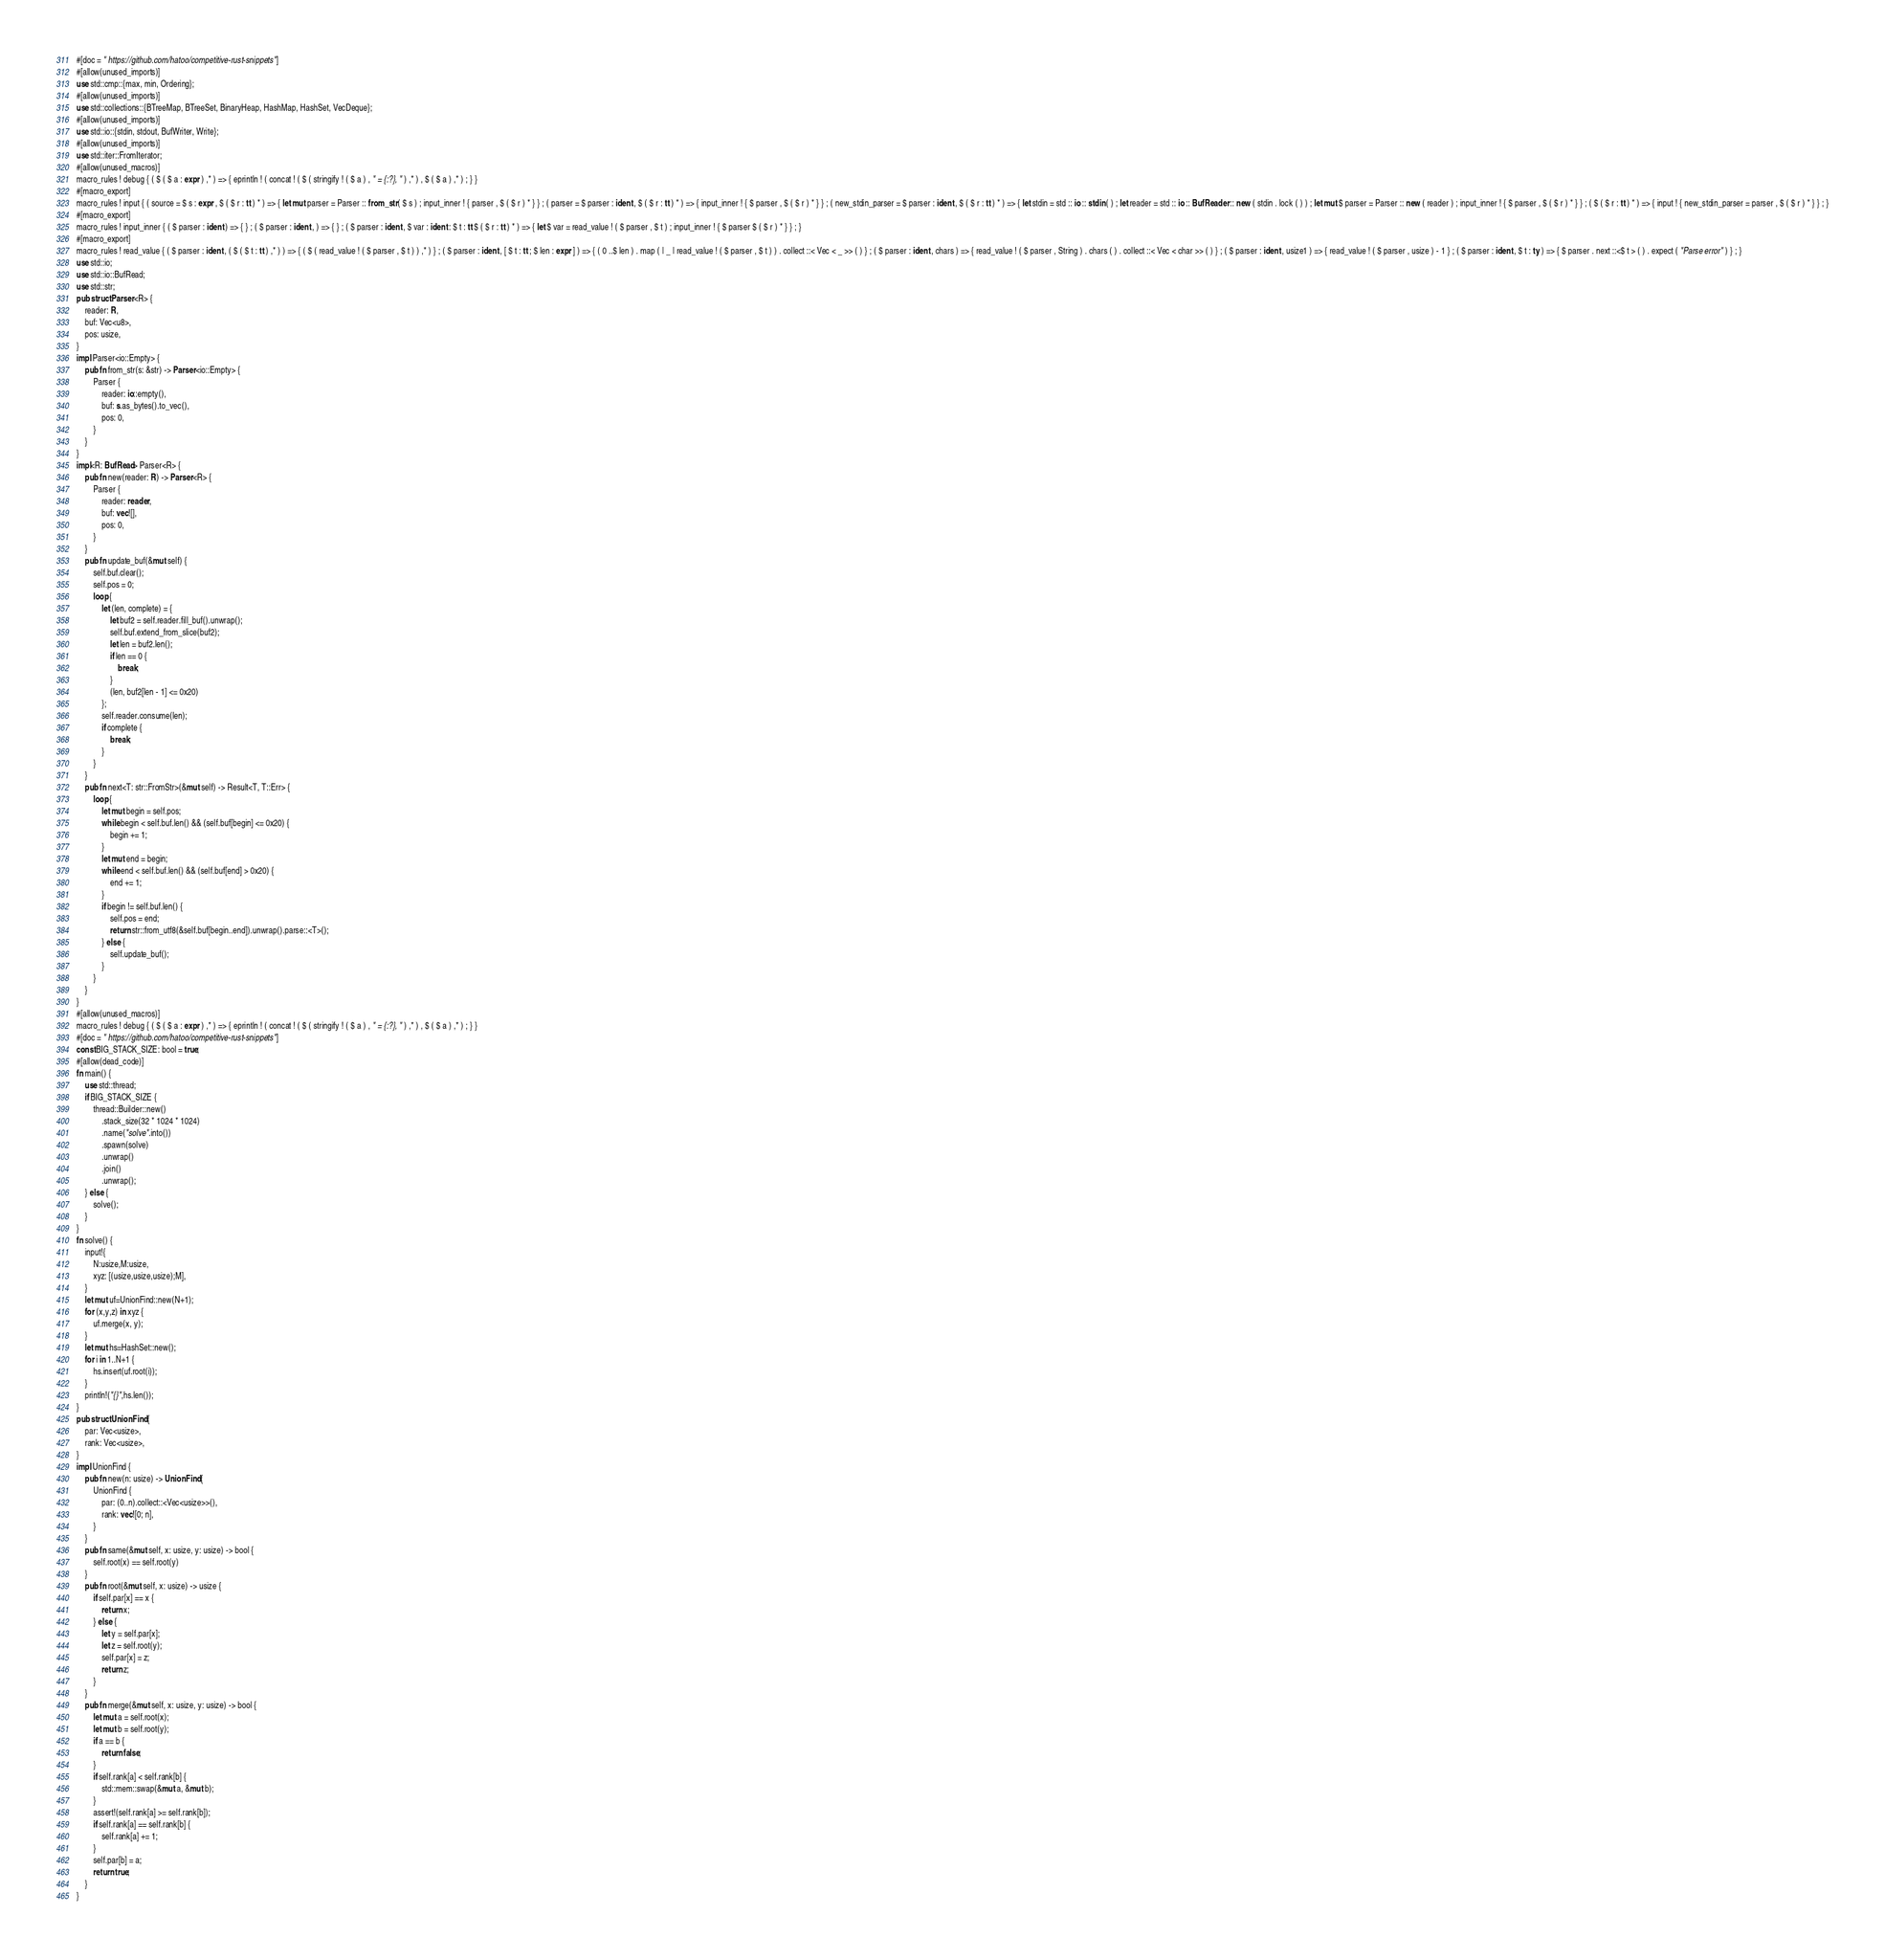Convert code to text. <code><loc_0><loc_0><loc_500><loc_500><_Rust_>#[doc = " https://github.com/hatoo/competitive-rust-snippets"]
#[allow(unused_imports)]
use std::cmp::{max, min, Ordering};
#[allow(unused_imports)]
use std::collections::{BTreeMap, BTreeSet, BinaryHeap, HashMap, HashSet, VecDeque};
#[allow(unused_imports)]
use std::io::{stdin, stdout, BufWriter, Write};
#[allow(unused_imports)]
use std::iter::FromIterator;
#[allow(unused_macros)]
macro_rules ! debug { ( $ ( $ a : expr ) ,* ) => { eprintln ! ( concat ! ( $ ( stringify ! ( $ a ) , " = {:?}, " ) ,* ) , $ ( $ a ) ,* ) ; } }
#[macro_export]
macro_rules ! input { ( source = $ s : expr , $ ( $ r : tt ) * ) => { let mut parser = Parser :: from_str ( $ s ) ; input_inner ! { parser , $ ( $ r ) * } } ; ( parser = $ parser : ident , $ ( $ r : tt ) * ) => { input_inner ! { $ parser , $ ( $ r ) * } } ; ( new_stdin_parser = $ parser : ident , $ ( $ r : tt ) * ) => { let stdin = std :: io :: stdin ( ) ; let reader = std :: io :: BufReader :: new ( stdin . lock ( ) ) ; let mut $ parser = Parser :: new ( reader ) ; input_inner ! { $ parser , $ ( $ r ) * } } ; ( $ ( $ r : tt ) * ) => { input ! { new_stdin_parser = parser , $ ( $ r ) * } } ; }
#[macro_export]
macro_rules ! input_inner { ( $ parser : ident ) => { } ; ( $ parser : ident , ) => { } ; ( $ parser : ident , $ var : ident : $ t : tt $ ( $ r : tt ) * ) => { let $ var = read_value ! ( $ parser , $ t ) ; input_inner ! { $ parser $ ( $ r ) * } } ; }
#[macro_export]
macro_rules ! read_value { ( $ parser : ident , ( $ ( $ t : tt ) ,* ) ) => { ( $ ( read_value ! ( $ parser , $ t ) ) ,* ) } ; ( $ parser : ident , [ $ t : tt ; $ len : expr ] ) => { ( 0 ..$ len ) . map ( | _ | read_value ! ( $ parser , $ t ) ) . collect ::< Vec < _ >> ( ) } ; ( $ parser : ident , chars ) => { read_value ! ( $ parser , String ) . chars ( ) . collect ::< Vec < char >> ( ) } ; ( $ parser : ident , usize1 ) => { read_value ! ( $ parser , usize ) - 1 } ; ( $ parser : ident , $ t : ty ) => { $ parser . next ::<$ t > ( ) . expect ( "Parse error" ) } ; }
use std::io;
use std::io::BufRead;
use std::str;
pub struct Parser<R> {
    reader: R,
    buf: Vec<u8>,
    pos: usize,
}
impl Parser<io::Empty> {
    pub fn from_str(s: &str) -> Parser<io::Empty> {
        Parser {
            reader: io::empty(),
            buf: s.as_bytes().to_vec(),
            pos: 0,
        }
    }
}
impl<R: BufRead> Parser<R> {
    pub fn new(reader: R) -> Parser<R> {
        Parser {
            reader: reader,
            buf: vec![],
            pos: 0,
        }
    }
    pub fn update_buf(&mut self) {
        self.buf.clear();
        self.pos = 0;
        loop {
            let (len, complete) = {
                let buf2 = self.reader.fill_buf().unwrap();
                self.buf.extend_from_slice(buf2);
                let len = buf2.len();
                if len == 0 {
                    break;
                }
                (len, buf2[len - 1] <= 0x20)
            };
            self.reader.consume(len);
            if complete {
                break;
            }
        }
    }
    pub fn next<T: str::FromStr>(&mut self) -> Result<T, T::Err> {
        loop {
            let mut begin = self.pos;
            while begin < self.buf.len() && (self.buf[begin] <= 0x20) {
                begin += 1;
            }
            let mut end = begin;
            while end < self.buf.len() && (self.buf[end] > 0x20) {
                end += 1;
            }
            if begin != self.buf.len() {
                self.pos = end;
                return str::from_utf8(&self.buf[begin..end]).unwrap().parse::<T>();
            } else {
                self.update_buf();
            }
        }
    }
}
#[allow(unused_macros)]
macro_rules ! debug { ( $ ( $ a : expr ) ,* ) => { eprintln ! ( concat ! ( $ ( stringify ! ( $ a ) , " = {:?}, " ) ,* ) , $ ( $ a ) ,* ) ; } }
#[doc = " https://github.com/hatoo/competitive-rust-snippets"]
const BIG_STACK_SIZE: bool = true;
#[allow(dead_code)]
fn main() {
    use std::thread;
    if BIG_STACK_SIZE {
        thread::Builder::new()
            .stack_size(32 * 1024 * 1024)
            .name("solve".into())
            .spawn(solve)
            .unwrap()
            .join()
            .unwrap();
    } else {
        solve();
    }
}
fn solve() {
    input!{
        N:usize,M:usize,
        xyz: [(usize,usize,usize);M],
    }
    let mut uf=UnionFind::new(N+1);
    for (x,y,z) in xyz {
        uf.merge(x, y);
    }
    let mut hs=HashSet::new();
    for i in 1..N+1 {
        hs.insert(uf.root(i));
    }
    println!("{}",hs.len());
}
pub struct UnionFind {
    par: Vec<usize>,
    rank: Vec<usize>,
}
impl UnionFind {
    pub fn new(n: usize) -> UnionFind {
        UnionFind {
            par: (0..n).collect::<Vec<usize>>(),
            rank: vec![0; n],
        }
    }
    pub fn same(&mut self, x: usize, y: usize) -> bool {
        self.root(x) == self.root(y)
    }
    pub fn root(&mut self, x: usize) -> usize {
        if self.par[x] == x {
            return x;
        } else {
            let y = self.par[x];
            let z = self.root(y);
            self.par[x] = z;
            return z;
        }
    }
    pub fn merge(&mut self, x: usize, y: usize) -> bool {
        let mut a = self.root(x);
        let mut b = self.root(y);
        if a == b {
            return false;
        }
        if self.rank[a] < self.rank[b] {
            std::mem::swap(&mut a, &mut b);
        }
        assert!(self.rank[a] >= self.rank[b]);
        if self.rank[a] == self.rank[b] {
            self.rank[a] += 1;
        }
        self.par[b] = a;
        return true;
    }
}</code> 